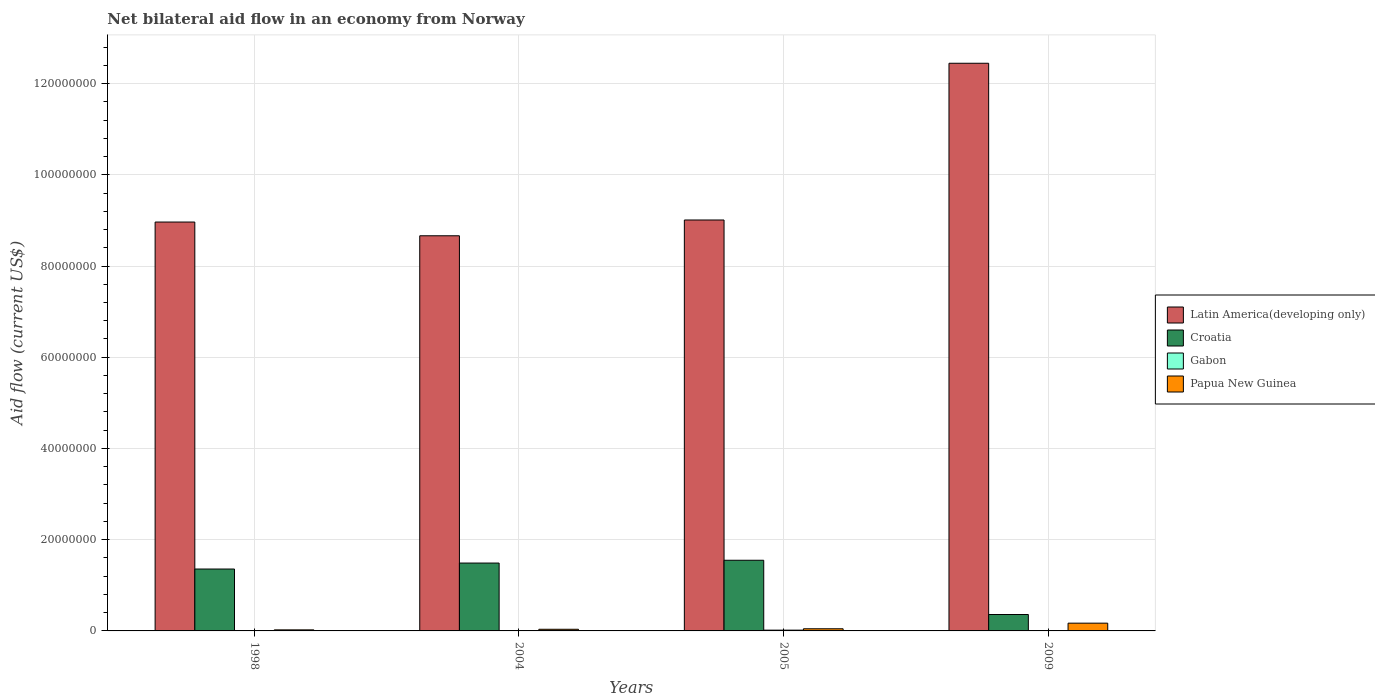How many different coloured bars are there?
Give a very brief answer. 4. Are the number of bars per tick equal to the number of legend labels?
Make the answer very short. Yes. Are the number of bars on each tick of the X-axis equal?
Provide a succinct answer. Yes. How many bars are there on the 1st tick from the left?
Give a very brief answer. 4. What is the label of the 4th group of bars from the left?
Offer a very short reply. 2009. In how many cases, is the number of bars for a given year not equal to the number of legend labels?
Make the answer very short. 0. What is the net bilateral aid flow in Latin America(developing only) in 2004?
Provide a short and direct response. 8.66e+07. Across all years, what is the maximum net bilateral aid flow in Papua New Guinea?
Give a very brief answer. 1.70e+06. Across all years, what is the minimum net bilateral aid flow in Latin America(developing only)?
Provide a short and direct response. 8.66e+07. In which year was the net bilateral aid flow in Gabon maximum?
Offer a very short reply. 2005. What is the total net bilateral aid flow in Latin America(developing only) in the graph?
Make the answer very short. 3.91e+08. What is the difference between the net bilateral aid flow in Papua New Guinea in 1998 and the net bilateral aid flow in Gabon in 2009?
Provide a short and direct response. 2.10e+05. What is the average net bilateral aid flow in Papua New Guinea per year?
Provide a succinct answer. 6.90e+05. In the year 2004, what is the difference between the net bilateral aid flow in Papua New Guinea and net bilateral aid flow in Gabon?
Your response must be concise. 2.90e+05. What is the ratio of the net bilateral aid flow in Croatia in 1998 to that in 2004?
Make the answer very short. 0.91. Is the difference between the net bilateral aid flow in Papua New Guinea in 1998 and 2005 greater than the difference between the net bilateral aid flow in Gabon in 1998 and 2005?
Keep it short and to the point. No. What is the difference between the highest and the lowest net bilateral aid flow in Papua New Guinea?
Provide a short and direct response. 1.47e+06. In how many years, is the net bilateral aid flow in Papua New Guinea greater than the average net bilateral aid flow in Papua New Guinea taken over all years?
Give a very brief answer. 1. Is the sum of the net bilateral aid flow in Gabon in 1998 and 2005 greater than the maximum net bilateral aid flow in Papua New Guinea across all years?
Ensure brevity in your answer.  No. Is it the case that in every year, the sum of the net bilateral aid flow in Latin America(developing only) and net bilateral aid flow in Papua New Guinea is greater than the sum of net bilateral aid flow in Croatia and net bilateral aid flow in Gabon?
Your answer should be compact. Yes. What does the 3rd bar from the left in 2005 represents?
Offer a very short reply. Gabon. What does the 3rd bar from the right in 2009 represents?
Your answer should be very brief. Croatia. Is it the case that in every year, the sum of the net bilateral aid flow in Croatia and net bilateral aid flow in Gabon is greater than the net bilateral aid flow in Papua New Guinea?
Keep it short and to the point. Yes. How many bars are there?
Offer a terse response. 16. How many years are there in the graph?
Your response must be concise. 4. Are the values on the major ticks of Y-axis written in scientific E-notation?
Ensure brevity in your answer.  No. Does the graph contain grids?
Make the answer very short. Yes. How are the legend labels stacked?
Your response must be concise. Vertical. What is the title of the graph?
Ensure brevity in your answer.  Net bilateral aid flow in an economy from Norway. What is the label or title of the Y-axis?
Provide a succinct answer. Aid flow (current US$). What is the Aid flow (current US$) in Latin America(developing only) in 1998?
Make the answer very short. 8.96e+07. What is the Aid flow (current US$) in Croatia in 1998?
Keep it short and to the point. 1.36e+07. What is the Aid flow (current US$) of Gabon in 1998?
Your answer should be compact. 10000. What is the Aid flow (current US$) of Papua New Guinea in 1998?
Keep it short and to the point. 2.30e+05. What is the Aid flow (current US$) of Latin America(developing only) in 2004?
Provide a short and direct response. 8.66e+07. What is the Aid flow (current US$) in Croatia in 2004?
Your answer should be very brief. 1.49e+07. What is the Aid flow (current US$) of Latin America(developing only) in 2005?
Make the answer very short. 9.01e+07. What is the Aid flow (current US$) of Croatia in 2005?
Offer a very short reply. 1.55e+07. What is the Aid flow (current US$) in Gabon in 2005?
Offer a very short reply. 1.70e+05. What is the Aid flow (current US$) of Papua New Guinea in 2005?
Provide a succinct answer. 4.70e+05. What is the Aid flow (current US$) in Latin America(developing only) in 2009?
Your answer should be very brief. 1.24e+08. What is the Aid flow (current US$) in Croatia in 2009?
Keep it short and to the point. 3.60e+06. What is the Aid flow (current US$) in Papua New Guinea in 2009?
Give a very brief answer. 1.70e+06. Across all years, what is the maximum Aid flow (current US$) in Latin America(developing only)?
Your response must be concise. 1.24e+08. Across all years, what is the maximum Aid flow (current US$) in Croatia?
Your response must be concise. 1.55e+07. Across all years, what is the maximum Aid flow (current US$) in Gabon?
Ensure brevity in your answer.  1.70e+05. Across all years, what is the maximum Aid flow (current US$) in Papua New Guinea?
Ensure brevity in your answer.  1.70e+06. Across all years, what is the minimum Aid flow (current US$) of Latin America(developing only)?
Provide a short and direct response. 8.66e+07. Across all years, what is the minimum Aid flow (current US$) of Croatia?
Keep it short and to the point. 3.60e+06. Across all years, what is the minimum Aid flow (current US$) of Gabon?
Offer a terse response. 10000. What is the total Aid flow (current US$) in Latin America(developing only) in the graph?
Ensure brevity in your answer.  3.91e+08. What is the total Aid flow (current US$) in Croatia in the graph?
Your answer should be very brief. 4.75e+07. What is the total Aid flow (current US$) of Papua New Guinea in the graph?
Your answer should be compact. 2.76e+06. What is the difference between the Aid flow (current US$) of Latin America(developing only) in 1998 and that in 2004?
Give a very brief answer. 3.01e+06. What is the difference between the Aid flow (current US$) in Croatia in 1998 and that in 2004?
Give a very brief answer. -1.31e+06. What is the difference between the Aid flow (current US$) in Gabon in 1998 and that in 2004?
Offer a very short reply. -6.00e+04. What is the difference between the Aid flow (current US$) of Papua New Guinea in 1998 and that in 2004?
Provide a succinct answer. -1.30e+05. What is the difference between the Aid flow (current US$) in Latin America(developing only) in 1998 and that in 2005?
Your answer should be very brief. -4.50e+05. What is the difference between the Aid flow (current US$) of Croatia in 1998 and that in 2005?
Your answer should be compact. -1.92e+06. What is the difference between the Aid flow (current US$) of Gabon in 1998 and that in 2005?
Ensure brevity in your answer.  -1.60e+05. What is the difference between the Aid flow (current US$) in Papua New Guinea in 1998 and that in 2005?
Keep it short and to the point. -2.40e+05. What is the difference between the Aid flow (current US$) in Latin America(developing only) in 1998 and that in 2009?
Offer a terse response. -3.48e+07. What is the difference between the Aid flow (current US$) in Croatia in 1998 and that in 2009?
Give a very brief answer. 9.97e+06. What is the difference between the Aid flow (current US$) in Gabon in 1998 and that in 2009?
Offer a very short reply. -10000. What is the difference between the Aid flow (current US$) of Papua New Guinea in 1998 and that in 2009?
Offer a very short reply. -1.47e+06. What is the difference between the Aid flow (current US$) of Latin America(developing only) in 2004 and that in 2005?
Your response must be concise. -3.46e+06. What is the difference between the Aid flow (current US$) in Croatia in 2004 and that in 2005?
Offer a very short reply. -6.10e+05. What is the difference between the Aid flow (current US$) of Gabon in 2004 and that in 2005?
Offer a terse response. -1.00e+05. What is the difference between the Aid flow (current US$) of Latin America(developing only) in 2004 and that in 2009?
Ensure brevity in your answer.  -3.78e+07. What is the difference between the Aid flow (current US$) in Croatia in 2004 and that in 2009?
Your response must be concise. 1.13e+07. What is the difference between the Aid flow (current US$) of Papua New Guinea in 2004 and that in 2009?
Give a very brief answer. -1.34e+06. What is the difference between the Aid flow (current US$) of Latin America(developing only) in 2005 and that in 2009?
Your response must be concise. -3.44e+07. What is the difference between the Aid flow (current US$) in Croatia in 2005 and that in 2009?
Your response must be concise. 1.19e+07. What is the difference between the Aid flow (current US$) of Gabon in 2005 and that in 2009?
Provide a succinct answer. 1.50e+05. What is the difference between the Aid flow (current US$) of Papua New Guinea in 2005 and that in 2009?
Your answer should be compact. -1.23e+06. What is the difference between the Aid flow (current US$) in Latin America(developing only) in 1998 and the Aid flow (current US$) in Croatia in 2004?
Make the answer very short. 7.48e+07. What is the difference between the Aid flow (current US$) in Latin America(developing only) in 1998 and the Aid flow (current US$) in Gabon in 2004?
Give a very brief answer. 8.96e+07. What is the difference between the Aid flow (current US$) of Latin America(developing only) in 1998 and the Aid flow (current US$) of Papua New Guinea in 2004?
Your answer should be very brief. 8.93e+07. What is the difference between the Aid flow (current US$) in Croatia in 1998 and the Aid flow (current US$) in Gabon in 2004?
Ensure brevity in your answer.  1.35e+07. What is the difference between the Aid flow (current US$) of Croatia in 1998 and the Aid flow (current US$) of Papua New Guinea in 2004?
Provide a short and direct response. 1.32e+07. What is the difference between the Aid flow (current US$) of Gabon in 1998 and the Aid flow (current US$) of Papua New Guinea in 2004?
Your response must be concise. -3.50e+05. What is the difference between the Aid flow (current US$) in Latin America(developing only) in 1998 and the Aid flow (current US$) in Croatia in 2005?
Keep it short and to the point. 7.42e+07. What is the difference between the Aid flow (current US$) of Latin America(developing only) in 1998 and the Aid flow (current US$) of Gabon in 2005?
Provide a succinct answer. 8.95e+07. What is the difference between the Aid flow (current US$) in Latin America(developing only) in 1998 and the Aid flow (current US$) in Papua New Guinea in 2005?
Make the answer very short. 8.92e+07. What is the difference between the Aid flow (current US$) in Croatia in 1998 and the Aid flow (current US$) in Gabon in 2005?
Make the answer very short. 1.34e+07. What is the difference between the Aid flow (current US$) of Croatia in 1998 and the Aid flow (current US$) of Papua New Guinea in 2005?
Offer a terse response. 1.31e+07. What is the difference between the Aid flow (current US$) in Gabon in 1998 and the Aid flow (current US$) in Papua New Guinea in 2005?
Your response must be concise. -4.60e+05. What is the difference between the Aid flow (current US$) in Latin America(developing only) in 1998 and the Aid flow (current US$) in Croatia in 2009?
Your response must be concise. 8.60e+07. What is the difference between the Aid flow (current US$) in Latin America(developing only) in 1998 and the Aid flow (current US$) in Gabon in 2009?
Provide a short and direct response. 8.96e+07. What is the difference between the Aid flow (current US$) in Latin America(developing only) in 1998 and the Aid flow (current US$) in Papua New Guinea in 2009?
Offer a terse response. 8.79e+07. What is the difference between the Aid flow (current US$) in Croatia in 1998 and the Aid flow (current US$) in Gabon in 2009?
Keep it short and to the point. 1.36e+07. What is the difference between the Aid flow (current US$) of Croatia in 1998 and the Aid flow (current US$) of Papua New Guinea in 2009?
Your response must be concise. 1.19e+07. What is the difference between the Aid flow (current US$) of Gabon in 1998 and the Aid flow (current US$) of Papua New Guinea in 2009?
Provide a short and direct response. -1.69e+06. What is the difference between the Aid flow (current US$) of Latin America(developing only) in 2004 and the Aid flow (current US$) of Croatia in 2005?
Provide a succinct answer. 7.11e+07. What is the difference between the Aid flow (current US$) in Latin America(developing only) in 2004 and the Aid flow (current US$) in Gabon in 2005?
Offer a terse response. 8.65e+07. What is the difference between the Aid flow (current US$) of Latin America(developing only) in 2004 and the Aid flow (current US$) of Papua New Guinea in 2005?
Provide a short and direct response. 8.62e+07. What is the difference between the Aid flow (current US$) of Croatia in 2004 and the Aid flow (current US$) of Gabon in 2005?
Make the answer very short. 1.47e+07. What is the difference between the Aid flow (current US$) in Croatia in 2004 and the Aid flow (current US$) in Papua New Guinea in 2005?
Your answer should be very brief. 1.44e+07. What is the difference between the Aid flow (current US$) of Gabon in 2004 and the Aid flow (current US$) of Papua New Guinea in 2005?
Provide a short and direct response. -4.00e+05. What is the difference between the Aid flow (current US$) in Latin America(developing only) in 2004 and the Aid flow (current US$) in Croatia in 2009?
Give a very brief answer. 8.30e+07. What is the difference between the Aid flow (current US$) in Latin America(developing only) in 2004 and the Aid flow (current US$) in Gabon in 2009?
Offer a terse response. 8.66e+07. What is the difference between the Aid flow (current US$) in Latin America(developing only) in 2004 and the Aid flow (current US$) in Papua New Guinea in 2009?
Provide a succinct answer. 8.49e+07. What is the difference between the Aid flow (current US$) in Croatia in 2004 and the Aid flow (current US$) in Gabon in 2009?
Ensure brevity in your answer.  1.49e+07. What is the difference between the Aid flow (current US$) in Croatia in 2004 and the Aid flow (current US$) in Papua New Guinea in 2009?
Keep it short and to the point. 1.32e+07. What is the difference between the Aid flow (current US$) of Gabon in 2004 and the Aid flow (current US$) of Papua New Guinea in 2009?
Provide a succinct answer. -1.63e+06. What is the difference between the Aid flow (current US$) of Latin America(developing only) in 2005 and the Aid flow (current US$) of Croatia in 2009?
Provide a succinct answer. 8.65e+07. What is the difference between the Aid flow (current US$) of Latin America(developing only) in 2005 and the Aid flow (current US$) of Gabon in 2009?
Your answer should be compact. 9.01e+07. What is the difference between the Aid flow (current US$) in Latin America(developing only) in 2005 and the Aid flow (current US$) in Papua New Guinea in 2009?
Provide a short and direct response. 8.84e+07. What is the difference between the Aid flow (current US$) in Croatia in 2005 and the Aid flow (current US$) in Gabon in 2009?
Provide a short and direct response. 1.55e+07. What is the difference between the Aid flow (current US$) in Croatia in 2005 and the Aid flow (current US$) in Papua New Guinea in 2009?
Your answer should be very brief. 1.38e+07. What is the difference between the Aid flow (current US$) of Gabon in 2005 and the Aid flow (current US$) of Papua New Guinea in 2009?
Your answer should be very brief. -1.53e+06. What is the average Aid flow (current US$) in Latin America(developing only) per year?
Offer a terse response. 9.77e+07. What is the average Aid flow (current US$) in Croatia per year?
Offer a very short reply. 1.19e+07. What is the average Aid flow (current US$) in Gabon per year?
Provide a succinct answer. 6.75e+04. What is the average Aid flow (current US$) in Papua New Guinea per year?
Give a very brief answer. 6.90e+05. In the year 1998, what is the difference between the Aid flow (current US$) of Latin America(developing only) and Aid flow (current US$) of Croatia?
Give a very brief answer. 7.61e+07. In the year 1998, what is the difference between the Aid flow (current US$) of Latin America(developing only) and Aid flow (current US$) of Gabon?
Offer a terse response. 8.96e+07. In the year 1998, what is the difference between the Aid flow (current US$) of Latin America(developing only) and Aid flow (current US$) of Papua New Guinea?
Your answer should be compact. 8.94e+07. In the year 1998, what is the difference between the Aid flow (current US$) of Croatia and Aid flow (current US$) of Gabon?
Ensure brevity in your answer.  1.36e+07. In the year 1998, what is the difference between the Aid flow (current US$) of Croatia and Aid flow (current US$) of Papua New Guinea?
Your answer should be compact. 1.33e+07. In the year 1998, what is the difference between the Aid flow (current US$) of Gabon and Aid flow (current US$) of Papua New Guinea?
Your answer should be very brief. -2.20e+05. In the year 2004, what is the difference between the Aid flow (current US$) in Latin America(developing only) and Aid flow (current US$) in Croatia?
Provide a short and direct response. 7.18e+07. In the year 2004, what is the difference between the Aid flow (current US$) of Latin America(developing only) and Aid flow (current US$) of Gabon?
Your answer should be very brief. 8.66e+07. In the year 2004, what is the difference between the Aid flow (current US$) in Latin America(developing only) and Aid flow (current US$) in Papua New Guinea?
Your answer should be compact. 8.63e+07. In the year 2004, what is the difference between the Aid flow (current US$) in Croatia and Aid flow (current US$) in Gabon?
Provide a short and direct response. 1.48e+07. In the year 2004, what is the difference between the Aid flow (current US$) of Croatia and Aid flow (current US$) of Papua New Guinea?
Provide a succinct answer. 1.45e+07. In the year 2005, what is the difference between the Aid flow (current US$) of Latin America(developing only) and Aid flow (current US$) of Croatia?
Your answer should be very brief. 7.46e+07. In the year 2005, what is the difference between the Aid flow (current US$) in Latin America(developing only) and Aid flow (current US$) in Gabon?
Give a very brief answer. 8.99e+07. In the year 2005, what is the difference between the Aid flow (current US$) of Latin America(developing only) and Aid flow (current US$) of Papua New Guinea?
Offer a very short reply. 8.96e+07. In the year 2005, what is the difference between the Aid flow (current US$) of Croatia and Aid flow (current US$) of Gabon?
Your answer should be very brief. 1.53e+07. In the year 2005, what is the difference between the Aid flow (current US$) in Croatia and Aid flow (current US$) in Papua New Guinea?
Keep it short and to the point. 1.50e+07. In the year 2009, what is the difference between the Aid flow (current US$) in Latin America(developing only) and Aid flow (current US$) in Croatia?
Make the answer very short. 1.21e+08. In the year 2009, what is the difference between the Aid flow (current US$) of Latin America(developing only) and Aid flow (current US$) of Gabon?
Offer a terse response. 1.24e+08. In the year 2009, what is the difference between the Aid flow (current US$) of Latin America(developing only) and Aid flow (current US$) of Papua New Guinea?
Offer a very short reply. 1.23e+08. In the year 2009, what is the difference between the Aid flow (current US$) in Croatia and Aid flow (current US$) in Gabon?
Provide a succinct answer. 3.58e+06. In the year 2009, what is the difference between the Aid flow (current US$) of Croatia and Aid flow (current US$) of Papua New Guinea?
Provide a short and direct response. 1.90e+06. In the year 2009, what is the difference between the Aid flow (current US$) of Gabon and Aid flow (current US$) of Papua New Guinea?
Provide a short and direct response. -1.68e+06. What is the ratio of the Aid flow (current US$) in Latin America(developing only) in 1998 to that in 2004?
Make the answer very short. 1.03. What is the ratio of the Aid flow (current US$) of Croatia in 1998 to that in 2004?
Provide a succinct answer. 0.91. What is the ratio of the Aid flow (current US$) in Gabon in 1998 to that in 2004?
Give a very brief answer. 0.14. What is the ratio of the Aid flow (current US$) in Papua New Guinea in 1998 to that in 2004?
Your answer should be very brief. 0.64. What is the ratio of the Aid flow (current US$) of Croatia in 1998 to that in 2005?
Give a very brief answer. 0.88. What is the ratio of the Aid flow (current US$) of Gabon in 1998 to that in 2005?
Give a very brief answer. 0.06. What is the ratio of the Aid flow (current US$) of Papua New Guinea in 1998 to that in 2005?
Provide a succinct answer. 0.49. What is the ratio of the Aid flow (current US$) in Latin America(developing only) in 1998 to that in 2009?
Ensure brevity in your answer.  0.72. What is the ratio of the Aid flow (current US$) in Croatia in 1998 to that in 2009?
Offer a terse response. 3.77. What is the ratio of the Aid flow (current US$) in Papua New Guinea in 1998 to that in 2009?
Your answer should be very brief. 0.14. What is the ratio of the Aid flow (current US$) in Latin America(developing only) in 2004 to that in 2005?
Your response must be concise. 0.96. What is the ratio of the Aid flow (current US$) in Croatia in 2004 to that in 2005?
Your response must be concise. 0.96. What is the ratio of the Aid flow (current US$) in Gabon in 2004 to that in 2005?
Your response must be concise. 0.41. What is the ratio of the Aid flow (current US$) of Papua New Guinea in 2004 to that in 2005?
Provide a succinct answer. 0.77. What is the ratio of the Aid flow (current US$) in Latin America(developing only) in 2004 to that in 2009?
Keep it short and to the point. 0.7. What is the ratio of the Aid flow (current US$) of Croatia in 2004 to that in 2009?
Your answer should be compact. 4.13. What is the ratio of the Aid flow (current US$) in Papua New Guinea in 2004 to that in 2009?
Offer a very short reply. 0.21. What is the ratio of the Aid flow (current US$) in Latin America(developing only) in 2005 to that in 2009?
Make the answer very short. 0.72. What is the ratio of the Aid flow (current US$) in Croatia in 2005 to that in 2009?
Give a very brief answer. 4.3. What is the ratio of the Aid flow (current US$) in Gabon in 2005 to that in 2009?
Your answer should be very brief. 8.5. What is the ratio of the Aid flow (current US$) in Papua New Guinea in 2005 to that in 2009?
Offer a terse response. 0.28. What is the difference between the highest and the second highest Aid flow (current US$) in Latin America(developing only)?
Provide a succinct answer. 3.44e+07. What is the difference between the highest and the second highest Aid flow (current US$) in Gabon?
Offer a terse response. 1.00e+05. What is the difference between the highest and the second highest Aid flow (current US$) in Papua New Guinea?
Provide a short and direct response. 1.23e+06. What is the difference between the highest and the lowest Aid flow (current US$) in Latin America(developing only)?
Provide a succinct answer. 3.78e+07. What is the difference between the highest and the lowest Aid flow (current US$) in Croatia?
Keep it short and to the point. 1.19e+07. What is the difference between the highest and the lowest Aid flow (current US$) in Papua New Guinea?
Offer a very short reply. 1.47e+06. 